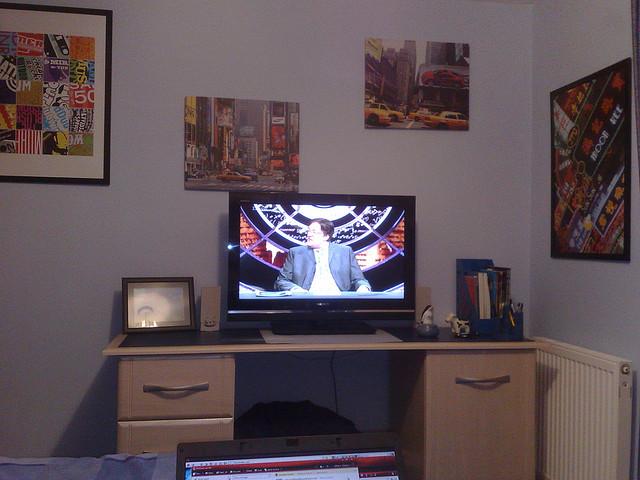Is the TV on?
Write a very short answer. Yes. How many people can be seen on the screen?
Quick response, please. 1. How many pictures on the wall?
Keep it brief. 4. What color is the cup sitting on the shelf holding pens and pencils?
Quick response, please. Blue. Is the TV a flat screen?
Be succinct. Yes. What show is displayed on the television?
Quick response, please. Talk show. What is on the center of the mantle?
Write a very short answer. Tv. What is on the display?
Be succinct. Man. What is the name of this piece of furniture?
Answer briefly. Desk. How many drawers are there?
Short answer required. 2. How many computer monitors are there?
Short answer required. 1. How many monitors are on the desk?
Give a very brief answer. 1. Is the television almost as big as the desk?
Keep it brief. No. What is in the left corner?
Write a very short answer. Picture. 